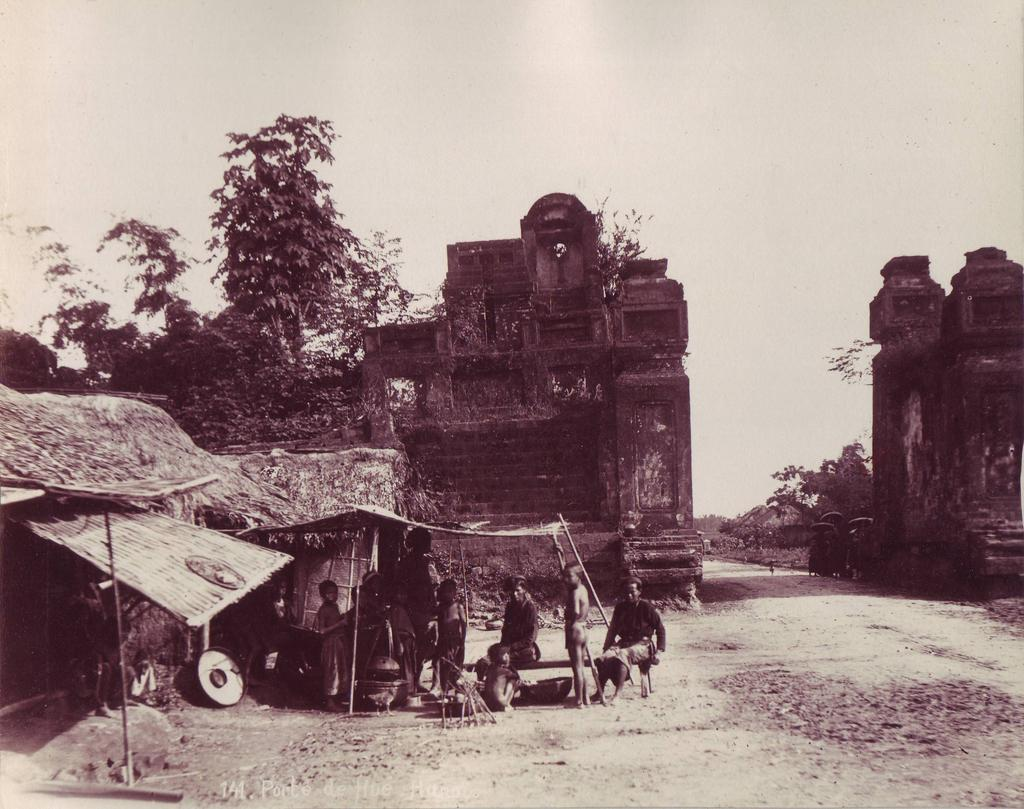Who or what is present in the image? There are people in the image. What type of structures can be seen in the image? There are huts in the image. What architectural features are visible in the background? There are walls in the background of the image. What type of natural environment is visible in the background? There are trees and the sky visible in the background of the image. How many baskets are being used by the people in the image? There is no mention of baskets in the image, so we cannot determine how many are being used. 